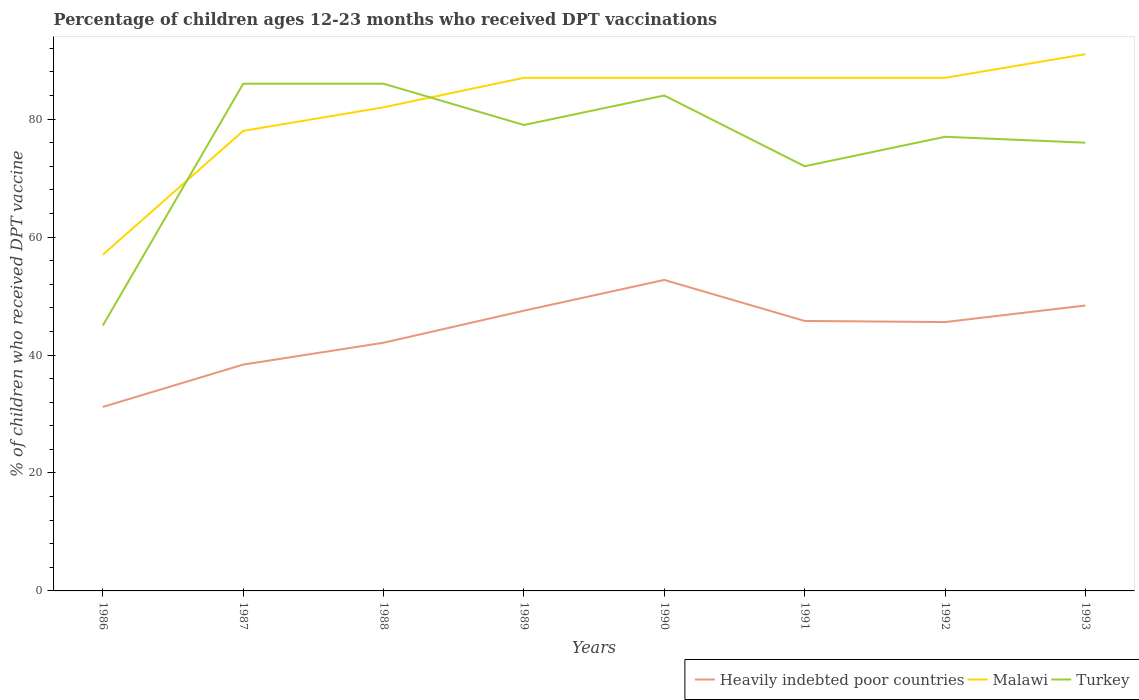Across all years, what is the maximum percentage of children who received DPT vaccination in Heavily indebted poor countries?
Keep it short and to the point. 31.19. What is the total percentage of children who received DPT vaccination in Heavily indebted poor countries in the graph?
Ensure brevity in your answer.  -14.35. What is the difference between the highest and the second highest percentage of children who received DPT vaccination in Malawi?
Ensure brevity in your answer.  34. What is the difference between the highest and the lowest percentage of children who received DPT vaccination in Malawi?
Give a very brief answer. 5. Is the percentage of children who received DPT vaccination in Turkey strictly greater than the percentage of children who received DPT vaccination in Malawi over the years?
Offer a very short reply. No. How many lines are there?
Your response must be concise. 3. Are the values on the major ticks of Y-axis written in scientific E-notation?
Your answer should be very brief. No. Does the graph contain grids?
Keep it short and to the point. No. How many legend labels are there?
Give a very brief answer. 3. What is the title of the graph?
Keep it short and to the point. Percentage of children ages 12-23 months who received DPT vaccinations. Does "Ethiopia" appear as one of the legend labels in the graph?
Give a very brief answer. No. What is the label or title of the X-axis?
Keep it short and to the point. Years. What is the label or title of the Y-axis?
Your answer should be very brief. % of children who received DPT vaccine. What is the % of children who received DPT vaccine in Heavily indebted poor countries in 1986?
Make the answer very short. 31.19. What is the % of children who received DPT vaccine in Malawi in 1986?
Your answer should be very brief. 57. What is the % of children who received DPT vaccine in Turkey in 1986?
Keep it short and to the point. 45. What is the % of children who received DPT vaccine in Heavily indebted poor countries in 1987?
Give a very brief answer. 38.37. What is the % of children who received DPT vaccine in Turkey in 1987?
Your answer should be compact. 86. What is the % of children who received DPT vaccine of Heavily indebted poor countries in 1988?
Keep it short and to the point. 42.08. What is the % of children who received DPT vaccine in Malawi in 1988?
Your answer should be very brief. 82. What is the % of children who received DPT vaccine in Turkey in 1988?
Your answer should be very brief. 86. What is the % of children who received DPT vaccine of Heavily indebted poor countries in 1989?
Provide a succinct answer. 47.51. What is the % of children who received DPT vaccine in Turkey in 1989?
Make the answer very short. 79. What is the % of children who received DPT vaccine of Heavily indebted poor countries in 1990?
Keep it short and to the point. 52.73. What is the % of children who received DPT vaccine in Heavily indebted poor countries in 1991?
Ensure brevity in your answer.  45.78. What is the % of children who received DPT vaccine of Malawi in 1991?
Give a very brief answer. 87. What is the % of children who received DPT vaccine of Turkey in 1991?
Your response must be concise. 72. What is the % of children who received DPT vaccine in Heavily indebted poor countries in 1992?
Your response must be concise. 45.59. What is the % of children who received DPT vaccine of Malawi in 1992?
Provide a succinct answer. 87. What is the % of children who received DPT vaccine of Heavily indebted poor countries in 1993?
Give a very brief answer. 48.39. What is the % of children who received DPT vaccine in Malawi in 1993?
Your answer should be very brief. 91. What is the % of children who received DPT vaccine of Turkey in 1993?
Your answer should be compact. 76. Across all years, what is the maximum % of children who received DPT vaccine in Heavily indebted poor countries?
Provide a succinct answer. 52.73. Across all years, what is the maximum % of children who received DPT vaccine of Malawi?
Your response must be concise. 91. Across all years, what is the maximum % of children who received DPT vaccine of Turkey?
Offer a terse response. 86. Across all years, what is the minimum % of children who received DPT vaccine of Heavily indebted poor countries?
Give a very brief answer. 31.19. What is the total % of children who received DPT vaccine in Heavily indebted poor countries in the graph?
Ensure brevity in your answer.  351.64. What is the total % of children who received DPT vaccine of Malawi in the graph?
Offer a terse response. 656. What is the total % of children who received DPT vaccine in Turkey in the graph?
Provide a succinct answer. 605. What is the difference between the % of children who received DPT vaccine in Heavily indebted poor countries in 1986 and that in 1987?
Your response must be concise. -7.18. What is the difference between the % of children who received DPT vaccine of Malawi in 1986 and that in 1987?
Your response must be concise. -21. What is the difference between the % of children who received DPT vaccine in Turkey in 1986 and that in 1987?
Offer a very short reply. -41. What is the difference between the % of children who received DPT vaccine in Heavily indebted poor countries in 1986 and that in 1988?
Offer a terse response. -10.89. What is the difference between the % of children who received DPT vaccine of Malawi in 1986 and that in 1988?
Your answer should be compact. -25. What is the difference between the % of children who received DPT vaccine in Turkey in 1986 and that in 1988?
Your answer should be compact. -41. What is the difference between the % of children who received DPT vaccine in Heavily indebted poor countries in 1986 and that in 1989?
Provide a short and direct response. -16.32. What is the difference between the % of children who received DPT vaccine in Malawi in 1986 and that in 1989?
Offer a very short reply. -30. What is the difference between the % of children who received DPT vaccine in Turkey in 1986 and that in 1989?
Make the answer very short. -34. What is the difference between the % of children who received DPT vaccine of Heavily indebted poor countries in 1986 and that in 1990?
Ensure brevity in your answer.  -21.53. What is the difference between the % of children who received DPT vaccine in Malawi in 1986 and that in 1990?
Provide a succinct answer. -30. What is the difference between the % of children who received DPT vaccine of Turkey in 1986 and that in 1990?
Provide a short and direct response. -39. What is the difference between the % of children who received DPT vaccine of Heavily indebted poor countries in 1986 and that in 1991?
Make the answer very short. -14.58. What is the difference between the % of children who received DPT vaccine of Heavily indebted poor countries in 1986 and that in 1992?
Give a very brief answer. -14.39. What is the difference between the % of children who received DPT vaccine of Malawi in 1986 and that in 1992?
Keep it short and to the point. -30. What is the difference between the % of children who received DPT vaccine in Turkey in 1986 and that in 1992?
Provide a succinct answer. -32. What is the difference between the % of children who received DPT vaccine of Heavily indebted poor countries in 1986 and that in 1993?
Your answer should be very brief. -17.2. What is the difference between the % of children who received DPT vaccine in Malawi in 1986 and that in 1993?
Your answer should be compact. -34. What is the difference between the % of children who received DPT vaccine in Turkey in 1986 and that in 1993?
Your answer should be very brief. -31. What is the difference between the % of children who received DPT vaccine of Heavily indebted poor countries in 1987 and that in 1988?
Keep it short and to the point. -3.71. What is the difference between the % of children who received DPT vaccine in Heavily indebted poor countries in 1987 and that in 1989?
Make the answer very short. -9.14. What is the difference between the % of children who received DPT vaccine of Malawi in 1987 and that in 1989?
Your answer should be very brief. -9. What is the difference between the % of children who received DPT vaccine of Heavily indebted poor countries in 1987 and that in 1990?
Your answer should be compact. -14.35. What is the difference between the % of children who received DPT vaccine of Heavily indebted poor countries in 1987 and that in 1991?
Provide a succinct answer. -7.4. What is the difference between the % of children who received DPT vaccine in Malawi in 1987 and that in 1991?
Your answer should be compact. -9. What is the difference between the % of children who received DPT vaccine in Heavily indebted poor countries in 1987 and that in 1992?
Offer a terse response. -7.21. What is the difference between the % of children who received DPT vaccine in Malawi in 1987 and that in 1992?
Offer a very short reply. -9. What is the difference between the % of children who received DPT vaccine in Turkey in 1987 and that in 1992?
Your response must be concise. 9. What is the difference between the % of children who received DPT vaccine of Heavily indebted poor countries in 1987 and that in 1993?
Keep it short and to the point. -10.02. What is the difference between the % of children who received DPT vaccine in Heavily indebted poor countries in 1988 and that in 1989?
Provide a succinct answer. -5.43. What is the difference between the % of children who received DPT vaccine in Heavily indebted poor countries in 1988 and that in 1990?
Provide a succinct answer. -10.65. What is the difference between the % of children who received DPT vaccine of Malawi in 1988 and that in 1990?
Ensure brevity in your answer.  -5. What is the difference between the % of children who received DPT vaccine of Turkey in 1988 and that in 1990?
Offer a very short reply. 2. What is the difference between the % of children who received DPT vaccine of Heavily indebted poor countries in 1988 and that in 1991?
Give a very brief answer. -3.7. What is the difference between the % of children who received DPT vaccine of Malawi in 1988 and that in 1991?
Give a very brief answer. -5. What is the difference between the % of children who received DPT vaccine of Heavily indebted poor countries in 1988 and that in 1992?
Your response must be concise. -3.5. What is the difference between the % of children who received DPT vaccine in Malawi in 1988 and that in 1992?
Make the answer very short. -5. What is the difference between the % of children who received DPT vaccine in Heavily indebted poor countries in 1988 and that in 1993?
Provide a succinct answer. -6.31. What is the difference between the % of children who received DPT vaccine in Heavily indebted poor countries in 1989 and that in 1990?
Keep it short and to the point. -5.22. What is the difference between the % of children who received DPT vaccine in Turkey in 1989 and that in 1990?
Offer a terse response. -5. What is the difference between the % of children who received DPT vaccine in Heavily indebted poor countries in 1989 and that in 1991?
Offer a very short reply. 1.74. What is the difference between the % of children who received DPT vaccine of Malawi in 1989 and that in 1991?
Offer a terse response. 0. What is the difference between the % of children who received DPT vaccine in Turkey in 1989 and that in 1991?
Keep it short and to the point. 7. What is the difference between the % of children who received DPT vaccine of Heavily indebted poor countries in 1989 and that in 1992?
Provide a short and direct response. 1.93. What is the difference between the % of children who received DPT vaccine in Malawi in 1989 and that in 1992?
Give a very brief answer. 0. What is the difference between the % of children who received DPT vaccine of Turkey in 1989 and that in 1992?
Give a very brief answer. 2. What is the difference between the % of children who received DPT vaccine in Heavily indebted poor countries in 1989 and that in 1993?
Provide a short and direct response. -0.88. What is the difference between the % of children who received DPT vaccine in Heavily indebted poor countries in 1990 and that in 1991?
Ensure brevity in your answer.  6.95. What is the difference between the % of children who received DPT vaccine in Heavily indebted poor countries in 1990 and that in 1992?
Keep it short and to the point. 7.14. What is the difference between the % of children who received DPT vaccine in Malawi in 1990 and that in 1992?
Your answer should be very brief. 0. What is the difference between the % of children who received DPT vaccine in Turkey in 1990 and that in 1992?
Your answer should be very brief. 7. What is the difference between the % of children who received DPT vaccine in Heavily indebted poor countries in 1990 and that in 1993?
Offer a very short reply. 4.33. What is the difference between the % of children who received DPT vaccine in Malawi in 1990 and that in 1993?
Offer a terse response. -4. What is the difference between the % of children who received DPT vaccine of Heavily indebted poor countries in 1991 and that in 1992?
Keep it short and to the point. 0.19. What is the difference between the % of children who received DPT vaccine in Malawi in 1991 and that in 1992?
Provide a succinct answer. 0. What is the difference between the % of children who received DPT vaccine in Turkey in 1991 and that in 1992?
Your answer should be compact. -5. What is the difference between the % of children who received DPT vaccine in Heavily indebted poor countries in 1991 and that in 1993?
Offer a very short reply. -2.62. What is the difference between the % of children who received DPT vaccine of Malawi in 1991 and that in 1993?
Ensure brevity in your answer.  -4. What is the difference between the % of children who received DPT vaccine of Heavily indebted poor countries in 1992 and that in 1993?
Offer a very short reply. -2.81. What is the difference between the % of children who received DPT vaccine of Heavily indebted poor countries in 1986 and the % of children who received DPT vaccine of Malawi in 1987?
Ensure brevity in your answer.  -46.81. What is the difference between the % of children who received DPT vaccine of Heavily indebted poor countries in 1986 and the % of children who received DPT vaccine of Turkey in 1987?
Offer a terse response. -54.81. What is the difference between the % of children who received DPT vaccine of Malawi in 1986 and the % of children who received DPT vaccine of Turkey in 1987?
Give a very brief answer. -29. What is the difference between the % of children who received DPT vaccine of Heavily indebted poor countries in 1986 and the % of children who received DPT vaccine of Malawi in 1988?
Provide a succinct answer. -50.81. What is the difference between the % of children who received DPT vaccine of Heavily indebted poor countries in 1986 and the % of children who received DPT vaccine of Turkey in 1988?
Give a very brief answer. -54.81. What is the difference between the % of children who received DPT vaccine of Heavily indebted poor countries in 1986 and the % of children who received DPT vaccine of Malawi in 1989?
Make the answer very short. -55.81. What is the difference between the % of children who received DPT vaccine in Heavily indebted poor countries in 1986 and the % of children who received DPT vaccine in Turkey in 1989?
Give a very brief answer. -47.81. What is the difference between the % of children who received DPT vaccine in Malawi in 1986 and the % of children who received DPT vaccine in Turkey in 1989?
Keep it short and to the point. -22. What is the difference between the % of children who received DPT vaccine in Heavily indebted poor countries in 1986 and the % of children who received DPT vaccine in Malawi in 1990?
Keep it short and to the point. -55.81. What is the difference between the % of children who received DPT vaccine of Heavily indebted poor countries in 1986 and the % of children who received DPT vaccine of Turkey in 1990?
Keep it short and to the point. -52.81. What is the difference between the % of children who received DPT vaccine in Heavily indebted poor countries in 1986 and the % of children who received DPT vaccine in Malawi in 1991?
Keep it short and to the point. -55.81. What is the difference between the % of children who received DPT vaccine of Heavily indebted poor countries in 1986 and the % of children who received DPT vaccine of Turkey in 1991?
Your answer should be very brief. -40.81. What is the difference between the % of children who received DPT vaccine of Heavily indebted poor countries in 1986 and the % of children who received DPT vaccine of Malawi in 1992?
Provide a succinct answer. -55.81. What is the difference between the % of children who received DPT vaccine of Heavily indebted poor countries in 1986 and the % of children who received DPT vaccine of Turkey in 1992?
Give a very brief answer. -45.81. What is the difference between the % of children who received DPT vaccine in Heavily indebted poor countries in 1986 and the % of children who received DPT vaccine in Malawi in 1993?
Your answer should be compact. -59.81. What is the difference between the % of children who received DPT vaccine in Heavily indebted poor countries in 1986 and the % of children who received DPT vaccine in Turkey in 1993?
Provide a short and direct response. -44.81. What is the difference between the % of children who received DPT vaccine of Heavily indebted poor countries in 1987 and the % of children who received DPT vaccine of Malawi in 1988?
Ensure brevity in your answer.  -43.63. What is the difference between the % of children who received DPT vaccine of Heavily indebted poor countries in 1987 and the % of children who received DPT vaccine of Turkey in 1988?
Offer a terse response. -47.63. What is the difference between the % of children who received DPT vaccine in Malawi in 1987 and the % of children who received DPT vaccine in Turkey in 1988?
Keep it short and to the point. -8. What is the difference between the % of children who received DPT vaccine in Heavily indebted poor countries in 1987 and the % of children who received DPT vaccine in Malawi in 1989?
Provide a short and direct response. -48.63. What is the difference between the % of children who received DPT vaccine of Heavily indebted poor countries in 1987 and the % of children who received DPT vaccine of Turkey in 1989?
Your answer should be compact. -40.63. What is the difference between the % of children who received DPT vaccine in Malawi in 1987 and the % of children who received DPT vaccine in Turkey in 1989?
Offer a very short reply. -1. What is the difference between the % of children who received DPT vaccine of Heavily indebted poor countries in 1987 and the % of children who received DPT vaccine of Malawi in 1990?
Offer a terse response. -48.63. What is the difference between the % of children who received DPT vaccine of Heavily indebted poor countries in 1987 and the % of children who received DPT vaccine of Turkey in 1990?
Your answer should be compact. -45.63. What is the difference between the % of children who received DPT vaccine of Malawi in 1987 and the % of children who received DPT vaccine of Turkey in 1990?
Keep it short and to the point. -6. What is the difference between the % of children who received DPT vaccine of Heavily indebted poor countries in 1987 and the % of children who received DPT vaccine of Malawi in 1991?
Offer a very short reply. -48.63. What is the difference between the % of children who received DPT vaccine of Heavily indebted poor countries in 1987 and the % of children who received DPT vaccine of Turkey in 1991?
Your response must be concise. -33.63. What is the difference between the % of children who received DPT vaccine in Malawi in 1987 and the % of children who received DPT vaccine in Turkey in 1991?
Make the answer very short. 6. What is the difference between the % of children who received DPT vaccine in Heavily indebted poor countries in 1987 and the % of children who received DPT vaccine in Malawi in 1992?
Your response must be concise. -48.63. What is the difference between the % of children who received DPT vaccine in Heavily indebted poor countries in 1987 and the % of children who received DPT vaccine in Turkey in 1992?
Your answer should be very brief. -38.63. What is the difference between the % of children who received DPT vaccine of Malawi in 1987 and the % of children who received DPT vaccine of Turkey in 1992?
Keep it short and to the point. 1. What is the difference between the % of children who received DPT vaccine in Heavily indebted poor countries in 1987 and the % of children who received DPT vaccine in Malawi in 1993?
Ensure brevity in your answer.  -52.63. What is the difference between the % of children who received DPT vaccine in Heavily indebted poor countries in 1987 and the % of children who received DPT vaccine in Turkey in 1993?
Your response must be concise. -37.63. What is the difference between the % of children who received DPT vaccine in Heavily indebted poor countries in 1988 and the % of children who received DPT vaccine in Malawi in 1989?
Provide a succinct answer. -44.92. What is the difference between the % of children who received DPT vaccine of Heavily indebted poor countries in 1988 and the % of children who received DPT vaccine of Turkey in 1989?
Give a very brief answer. -36.92. What is the difference between the % of children who received DPT vaccine in Heavily indebted poor countries in 1988 and the % of children who received DPT vaccine in Malawi in 1990?
Ensure brevity in your answer.  -44.92. What is the difference between the % of children who received DPT vaccine in Heavily indebted poor countries in 1988 and the % of children who received DPT vaccine in Turkey in 1990?
Your answer should be compact. -41.92. What is the difference between the % of children who received DPT vaccine in Heavily indebted poor countries in 1988 and the % of children who received DPT vaccine in Malawi in 1991?
Offer a terse response. -44.92. What is the difference between the % of children who received DPT vaccine of Heavily indebted poor countries in 1988 and the % of children who received DPT vaccine of Turkey in 1991?
Your answer should be very brief. -29.92. What is the difference between the % of children who received DPT vaccine of Malawi in 1988 and the % of children who received DPT vaccine of Turkey in 1991?
Make the answer very short. 10. What is the difference between the % of children who received DPT vaccine in Heavily indebted poor countries in 1988 and the % of children who received DPT vaccine in Malawi in 1992?
Your response must be concise. -44.92. What is the difference between the % of children who received DPT vaccine of Heavily indebted poor countries in 1988 and the % of children who received DPT vaccine of Turkey in 1992?
Ensure brevity in your answer.  -34.92. What is the difference between the % of children who received DPT vaccine of Malawi in 1988 and the % of children who received DPT vaccine of Turkey in 1992?
Keep it short and to the point. 5. What is the difference between the % of children who received DPT vaccine in Heavily indebted poor countries in 1988 and the % of children who received DPT vaccine in Malawi in 1993?
Offer a very short reply. -48.92. What is the difference between the % of children who received DPT vaccine in Heavily indebted poor countries in 1988 and the % of children who received DPT vaccine in Turkey in 1993?
Give a very brief answer. -33.92. What is the difference between the % of children who received DPT vaccine of Malawi in 1988 and the % of children who received DPT vaccine of Turkey in 1993?
Keep it short and to the point. 6. What is the difference between the % of children who received DPT vaccine of Heavily indebted poor countries in 1989 and the % of children who received DPT vaccine of Malawi in 1990?
Your answer should be very brief. -39.49. What is the difference between the % of children who received DPT vaccine in Heavily indebted poor countries in 1989 and the % of children who received DPT vaccine in Turkey in 1990?
Ensure brevity in your answer.  -36.49. What is the difference between the % of children who received DPT vaccine in Heavily indebted poor countries in 1989 and the % of children who received DPT vaccine in Malawi in 1991?
Offer a very short reply. -39.49. What is the difference between the % of children who received DPT vaccine of Heavily indebted poor countries in 1989 and the % of children who received DPT vaccine of Turkey in 1991?
Make the answer very short. -24.49. What is the difference between the % of children who received DPT vaccine in Heavily indebted poor countries in 1989 and the % of children who received DPT vaccine in Malawi in 1992?
Make the answer very short. -39.49. What is the difference between the % of children who received DPT vaccine of Heavily indebted poor countries in 1989 and the % of children who received DPT vaccine of Turkey in 1992?
Keep it short and to the point. -29.49. What is the difference between the % of children who received DPT vaccine of Heavily indebted poor countries in 1989 and the % of children who received DPT vaccine of Malawi in 1993?
Keep it short and to the point. -43.49. What is the difference between the % of children who received DPT vaccine of Heavily indebted poor countries in 1989 and the % of children who received DPT vaccine of Turkey in 1993?
Provide a succinct answer. -28.49. What is the difference between the % of children who received DPT vaccine of Malawi in 1989 and the % of children who received DPT vaccine of Turkey in 1993?
Keep it short and to the point. 11. What is the difference between the % of children who received DPT vaccine in Heavily indebted poor countries in 1990 and the % of children who received DPT vaccine in Malawi in 1991?
Give a very brief answer. -34.27. What is the difference between the % of children who received DPT vaccine of Heavily indebted poor countries in 1990 and the % of children who received DPT vaccine of Turkey in 1991?
Your answer should be very brief. -19.27. What is the difference between the % of children who received DPT vaccine in Heavily indebted poor countries in 1990 and the % of children who received DPT vaccine in Malawi in 1992?
Provide a succinct answer. -34.27. What is the difference between the % of children who received DPT vaccine of Heavily indebted poor countries in 1990 and the % of children who received DPT vaccine of Turkey in 1992?
Keep it short and to the point. -24.27. What is the difference between the % of children who received DPT vaccine of Heavily indebted poor countries in 1990 and the % of children who received DPT vaccine of Malawi in 1993?
Your answer should be compact. -38.27. What is the difference between the % of children who received DPT vaccine of Heavily indebted poor countries in 1990 and the % of children who received DPT vaccine of Turkey in 1993?
Ensure brevity in your answer.  -23.27. What is the difference between the % of children who received DPT vaccine in Malawi in 1990 and the % of children who received DPT vaccine in Turkey in 1993?
Offer a terse response. 11. What is the difference between the % of children who received DPT vaccine in Heavily indebted poor countries in 1991 and the % of children who received DPT vaccine in Malawi in 1992?
Provide a succinct answer. -41.22. What is the difference between the % of children who received DPT vaccine of Heavily indebted poor countries in 1991 and the % of children who received DPT vaccine of Turkey in 1992?
Give a very brief answer. -31.22. What is the difference between the % of children who received DPT vaccine in Heavily indebted poor countries in 1991 and the % of children who received DPT vaccine in Malawi in 1993?
Your answer should be very brief. -45.22. What is the difference between the % of children who received DPT vaccine in Heavily indebted poor countries in 1991 and the % of children who received DPT vaccine in Turkey in 1993?
Give a very brief answer. -30.22. What is the difference between the % of children who received DPT vaccine in Heavily indebted poor countries in 1992 and the % of children who received DPT vaccine in Malawi in 1993?
Offer a terse response. -45.41. What is the difference between the % of children who received DPT vaccine in Heavily indebted poor countries in 1992 and the % of children who received DPT vaccine in Turkey in 1993?
Make the answer very short. -30.41. What is the average % of children who received DPT vaccine of Heavily indebted poor countries per year?
Your response must be concise. 43.96. What is the average % of children who received DPT vaccine in Malawi per year?
Your answer should be compact. 82. What is the average % of children who received DPT vaccine in Turkey per year?
Your answer should be compact. 75.62. In the year 1986, what is the difference between the % of children who received DPT vaccine in Heavily indebted poor countries and % of children who received DPT vaccine in Malawi?
Your answer should be compact. -25.81. In the year 1986, what is the difference between the % of children who received DPT vaccine of Heavily indebted poor countries and % of children who received DPT vaccine of Turkey?
Give a very brief answer. -13.81. In the year 1986, what is the difference between the % of children who received DPT vaccine of Malawi and % of children who received DPT vaccine of Turkey?
Keep it short and to the point. 12. In the year 1987, what is the difference between the % of children who received DPT vaccine of Heavily indebted poor countries and % of children who received DPT vaccine of Malawi?
Offer a terse response. -39.63. In the year 1987, what is the difference between the % of children who received DPT vaccine of Heavily indebted poor countries and % of children who received DPT vaccine of Turkey?
Keep it short and to the point. -47.63. In the year 1987, what is the difference between the % of children who received DPT vaccine of Malawi and % of children who received DPT vaccine of Turkey?
Offer a terse response. -8. In the year 1988, what is the difference between the % of children who received DPT vaccine of Heavily indebted poor countries and % of children who received DPT vaccine of Malawi?
Your answer should be very brief. -39.92. In the year 1988, what is the difference between the % of children who received DPT vaccine in Heavily indebted poor countries and % of children who received DPT vaccine in Turkey?
Keep it short and to the point. -43.92. In the year 1989, what is the difference between the % of children who received DPT vaccine in Heavily indebted poor countries and % of children who received DPT vaccine in Malawi?
Offer a very short reply. -39.49. In the year 1989, what is the difference between the % of children who received DPT vaccine in Heavily indebted poor countries and % of children who received DPT vaccine in Turkey?
Offer a terse response. -31.49. In the year 1990, what is the difference between the % of children who received DPT vaccine in Heavily indebted poor countries and % of children who received DPT vaccine in Malawi?
Your answer should be compact. -34.27. In the year 1990, what is the difference between the % of children who received DPT vaccine of Heavily indebted poor countries and % of children who received DPT vaccine of Turkey?
Ensure brevity in your answer.  -31.27. In the year 1991, what is the difference between the % of children who received DPT vaccine in Heavily indebted poor countries and % of children who received DPT vaccine in Malawi?
Offer a terse response. -41.22. In the year 1991, what is the difference between the % of children who received DPT vaccine in Heavily indebted poor countries and % of children who received DPT vaccine in Turkey?
Provide a short and direct response. -26.22. In the year 1991, what is the difference between the % of children who received DPT vaccine in Malawi and % of children who received DPT vaccine in Turkey?
Your response must be concise. 15. In the year 1992, what is the difference between the % of children who received DPT vaccine in Heavily indebted poor countries and % of children who received DPT vaccine in Malawi?
Give a very brief answer. -41.41. In the year 1992, what is the difference between the % of children who received DPT vaccine of Heavily indebted poor countries and % of children who received DPT vaccine of Turkey?
Your answer should be compact. -31.41. In the year 1992, what is the difference between the % of children who received DPT vaccine in Malawi and % of children who received DPT vaccine in Turkey?
Your answer should be compact. 10. In the year 1993, what is the difference between the % of children who received DPT vaccine of Heavily indebted poor countries and % of children who received DPT vaccine of Malawi?
Offer a very short reply. -42.61. In the year 1993, what is the difference between the % of children who received DPT vaccine of Heavily indebted poor countries and % of children who received DPT vaccine of Turkey?
Make the answer very short. -27.61. What is the ratio of the % of children who received DPT vaccine of Heavily indebted poor countries in 1986 to that in 1987?
Offer a terse response. 0.81. What is the ratio of the % of children who received DPT vaccine of Malawi in 1986 to that in 1987?
Your answer should be compact. 0.73. What is the ratio of the % of children who received DPT vaccine in Turkey in 1986 to that in 1987?
Keep it short and to the point. 0.52. What is the ratio of the % of children who received DPT vaccine of Heavily indebted poor countries in 1986 to that in 1988?
Your answer should be very brief. 0.74. What is the ratio of the % of children who received DPT vaccine of Malawi in 1986 to that in 1988?
Provide a short and direct response. 0.7. What is the ratio of the % of children who received DPT vaccine in Turkey in 1986 to that in 1988?
Keep it short and to the point. 0.52. What is the ratio of the % of children who received DPT vaccine of Heavily indebted poor countries in 1986 to that in 1989?
Your answer should be very brief. 0.66. What is the ratio of the % of children who received DPT vaccine in Malawi in 1986 to that in 1989?
Your answer should be very brief. 0.66. What is the ratio of the % of children who received DPT vaccine of Turkey in 1986 to that in 1989?
Your answer should be compact. 0.57. What is the ratio of the % of children who received DPT vaccine of Heavily indebted poor countries in 1986 to that in 1990?
Your answer should be very brief. 0.59. What is the ratio of the % of children who received DPT vaccine of Malawi in 1986 to that in 1990?
Your answer should be very brief. 0.66. What is the ratio of the % of children who received DPT vaccine of Turkey in 1986 to that in 1990?
Keep it short and to the point. 0.54. What is the ratio of the % of children who received DPT vaccine of Heavily indebted poor countries in 1986 to that in 1991?
Give a very brief answer. 0.68. What is the ratio of the % of children who received DPT vaccine in Malawi in 1986 to that in 1991?
Provide a short and direct response. 0.66. What is the ratio of the % of children who received DPT vaccine of Heavily indebted poor countries in 1986 to that in 1992?
Give a very brief answer. 0.68. What is the ratio of the % of children who received DPT vaccine of Malawi in 1986 to that in 1992?
Your answer should be compact. 0.66. What is the ratio of the % of children who received DPT vaccine of Turkey in 1986 to that in 1992?
Your answer should be very brief. 0.58. What is the ratio of the % of children who received DPT vaccine of Heavily indebted poor countries in 1986 to that in 1993?
Provide a succinct answer. 0.64. What is the ratio of the % of children who received DPT vaccine in Malawi in 1986 to that in 1993?
Your answer should be compact. 0.63. What is the ratio of the % of children who received DPT vaccine in Turkey in 1986 to that in 1993?
Your answer should be very brief. 0.59. What is the ratio of the % of children who received DPT vaccine in Heavily indebted poor countries in 1987 to that in 1988?
Offer a very short reply. 0.91. What is the ratio of the % of children who received DPT vaccine in Malawi in 1987 to that in 1988?
Provide a short and direct response. 0.95. What is the ratio of the % of children who received DPT vaccine of Heavily indebted poor countries in 1987 to that in 1989?
Keep it short and to the point. 0.81. What is the ratio of the % of children who received DPT vaccine in Malawi in 1987 to that in 1989?
Provide a short and direct response. 0.9. What is the ratio of the % of children who received DPT vaccine of Turkey in 1987 to that in 1989?
Give a very brief answer. 1.09. What is the ratio of the % of children who received DPT vaccine of Heavily indebted poor countries in 1987 to that in 1990?
Offer a terse response. 0.73. What is the ratio of the % of children who received DPT vaccine in Malawi in 1987 to that in 1990?
Offer a terse response. 0.9. What is the ratio of the % of children who received DPT vaccine in Turkey in 1987 to that in 1990?
Ensure brevity in your answer.  1.02. What is the ratio of the % of children who received DPT vaccine of Heavily indebted poor countries in 1987 to that in 1991?
Your answer should be compact. 0.84. What is the ratio of the % of children who received DPT vaccine in Malawi in 1987 to that in 1991?
Ensure brevity in your answer.  0.9. What is the ratio of the % of children who received DPT vaccine in Turkey in 1987 to that in 1991?
Make the answer very short. 1.19. What is the ratio of the % of children who received DPT vaccine of Heavily indebted poor countries in 1987 to that in 1992?
Offer a terse response. 0.84. What is the ratio of the % of children who received DPT vaccine of Malawi in 1987 to that in 1992?
Offer a very short reply. 0.9. What is the ratio of the % of children who received DPT vaccine in Turkey in 1987 to that in 1992?
Provide a short and direct response. 1.12. What is the ratio of the % of children who received DPT vaccine in Heavily indebted poor countries in 1987 to that in 1993?
Offer a terse response. 0.79. What is the ratio of the % of children who received DPT vaccine in Malawi in 1987 to that in 1993?
Give a very brief answer. 0.86. What is the ratio of the % of children who received DPT vaccine in Turkey in 1987 to that in 1993?
Give a very brief answer. 1.13. What is the ratio of the % of children who received DPT vaccine in Heavily indebted poor countries in 1988 to that in 1989?
Ensure brevity in your answer.  0.89. What is the ratio of the % of children who received DPT vaccine of Malawi in 1988 to that in 1989?
Your answer should be very brief. 0.94. What is the ratio of the % of children who received DPT vaccine of Turkey in 1988 to that in 1989?
Your answer should be very brief. 1.09. What is the ratio of the % of children who received DPT vaccine of Heavily indebted poor countries in 1988 to that in 1990?
Keep it short and to the point. 0.8. What is the ratio of the % of children who received DPT vaccine in Malawi in 1988 to that in 1990?
Give a very brief answer. 0.94. What is the ratio of the % of children who received DPT vaccine in Turkey in 1988 to that in 1990?
Provide a succinct answer. 1.02. What is the ratio of the % of children who received DPT vaccine of Heavily indebted poor countries in 1988 to that in 1991?
Your answer should be compact. 0.92. What is the ratio of the % of children who received DPT vaccine in Malawi in 1988 to that in 1991?
Ensure brevity in your answer.  0.94. What is the ratio of the % of children who received DPT vaccine of Turkey in 1988 to that in 1991?
Make the answer very short. 1.19. What is the ratio of the % of children who received DPT vaccine in Malawi in 1988 to that in 1992?
Ensure brevity in your answer.  0.94. What is the ratio of the % of children who received DPT vaccine in Turkey in 1988 to that in 1992?
Your answer should be very brief. 1.12. What is the ratio of the % of children who received DPT vaccine in Heavily indebted poor countries in 1988 to that in 1993?
Offer a very short reply. 0.87. What is the ratio of the % of children who received DPT vaccine of Malawi in 1988 to that in 1993?
Provide a short and direct response. 0.9. What is the ratio of the % of children who received DPT vaccine in Turkey in 1988 to that in 1993?
Your answer should be compact. 1.13. What is the ratio of the % of children who received DPT vaccine of Heavily indebted poor countries in 1989 to that in 1990?
Give a very brief answer. 0.9. What is the ratio of the % of children who received DPT vaccine of Turkey in 1989 to that in 1990?
Offer a very short reply. 0.94. What is the ratio of the % of children who received DPT vaccine of Heavily indebted poor countries in 1989 to that in 1991?
Provide a succinct answer. 1.04. What is the ratio of the % of children who received DPT vaccine of Malawi in 1989 to that in 1991?
Your answer should be compact. 1. What is the ratio of the % of children who received DPT vaccine in Turkey in 1989 to that in 1991?
Your answer should be compact. 1.1. What is the ratio of the % of children who received DPT vaccine of Heavily indebted poor countries in 1989 to that in 1992?
Offer a terse response. 1.04. What is the ratio of the % of children who received DPT vaccine of Malawi in 1989 to that in 1992?
Provide a succinct answer. 1. What is the ratio of the % of children who received DPT vaccine of Heavily indebted poor countries in 1989 to that in 1993?
Your response must be concise. 0.98. What is the ratio of the % of children who received DPT vaccine in Malawi in 1989 to that in 1993?
Make the answer very short. 0.96. What is the ratio of the % of children who received DPT vaccine in Turkey in 1989 to that in 1993?
Provide a short and direct response. 1.04. What is the ratio of the % of children who received DPT vaccine of Heavily indebted poor countries in 1990 to that in 1991?
Provide a succinct answer. 1.15. What is the ratio of the % of children who received DPT vaccine in Malawi in 1990 to that in 1991?
Offer a very short reply. 1. What is the ratio of the % of children who received DPT vaccine in Turkey in 1990 to that in 1991?
Offer a terse response. 1.17. What is the ratio of the % of children who received DPT vaccine in Heavily indebted poor countries in 1990 to that in 1992?
Offer a very short reply. 1.16. What is the ratio of the % of children who received DPT vaccine in Malawi in 1990 to that in 1992?
Ensure brevity in your answer.  1. What is the ratio of the % of children who received DPT vaccine of Heavily indebted poor countries in 1990 to that in 1993?
Your answer should be very brief. 1.09. What is the ratio of the % of children who received DPT vaccine in Malawi in 1990 to that in 1993?
Offer a terse response. 0.96. What is the ratio of the % of children who received DPT vaccine of Turkey in 1990 to that in 1993?
Provide a succinct answer. 1.11. What is the ratio of the % of children who received DPT vaccine of Turkey in 1991 to that in 1992?
Give a very brief answer. 0.94. What is the ratio of the % of children who received DPT vaccine in Heavily indebted poor countries in 1991 to that in 1993?
Make the answer very short. 0.95. What is the ratio of the % of children who received DPT vaccine of Malawi in 1991 to that in 1993?
Provide a short and direct response. 0.96. What is the ratio of the % of children who received DPT vaccine in Turkey in 1991 to that in 1993?
Provide a short and direct response. 0.95. What is the ratio of the % of children who received DPT vaccine of Heavily indebted poor countries in 1992 to that in 1993?
Your answer should be compact. 0.94. What is the ratio of the % of children who received DPT vaccine in Malawi in 1992 to that in 1993?
Make the answer very short. 0.96. What is the ratio of the % of children who received DPT vaccine in Turkey in 1992 to that in 1993?
Keep it short and to the point. 1.01. What is the difference between the highest and the second highest % of children who received DPT vaccine of Heavily indebted poor countries?
Your response must be concise. 4.33. What is the difference between the highest and the lowest % of children who received DPT vaccine in Heavily indebted poor countries?
Ensure brevity in your answer.  21.53. 